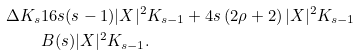Convert formula to latex. <formula><loc_0><loc_0><loc_500><loc_500>\Delta K _ { s } & 1 6 s ( s - 1 ) | X | ^ { 2 } K _ { s - 1 } + 4 s \left ( 2 \rho + 2 \right ) | X | ^ { 2 } K _ { s - 1 } \\ & B ( s ) | X | ^ { 2 } K _ { s - 1 } .</formula> 